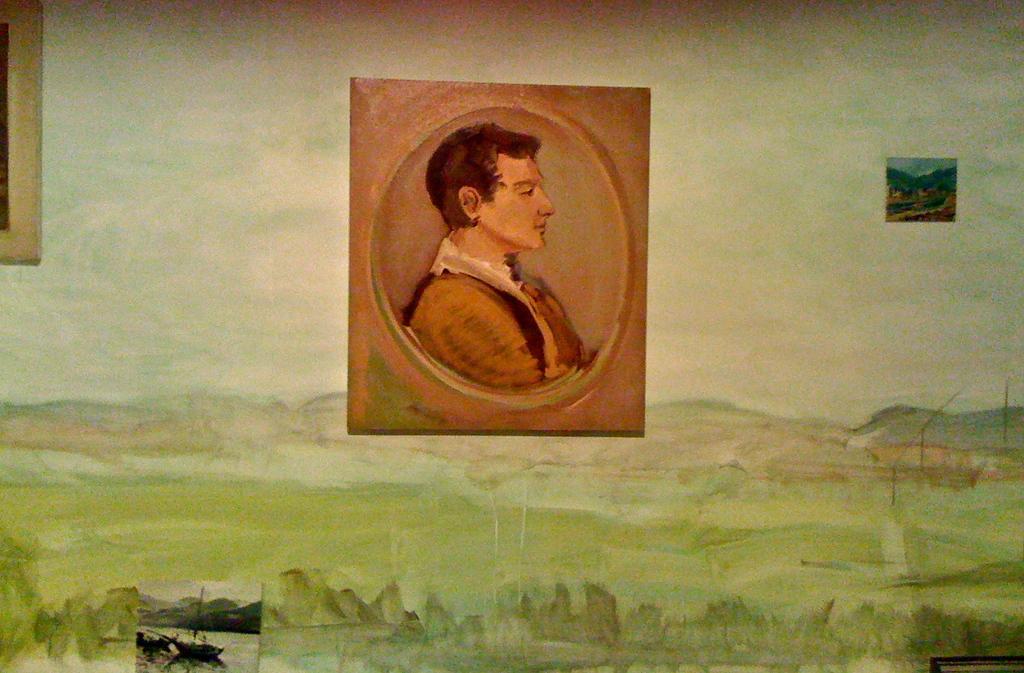Describe this image in one or two sentences. This picture describes about painting. 